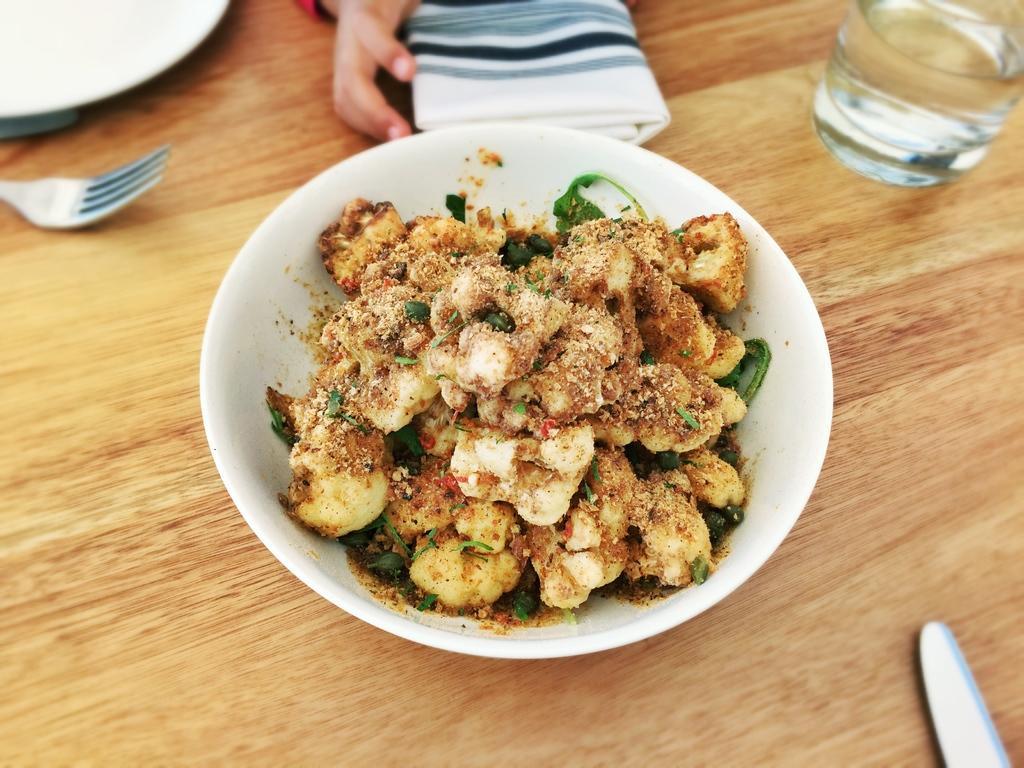Could you give a brief overview of what you see in this image? In this picture I can see a white bowl in front, on which there is food which is of green and brown color and the bowl is on the brown color surface and I can see a glass, a knife and a fork. On the top of this picture I can see a white color plate, a cloth and a hand of a person. 